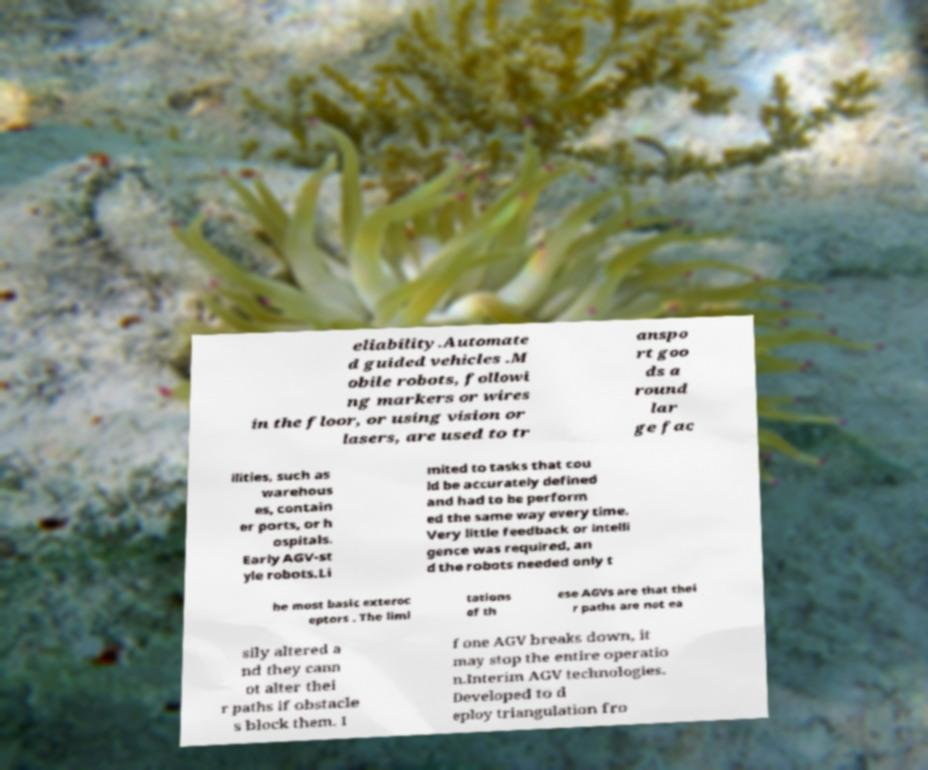For documentation purposes, I need the text within this image transcribed. Could you provide that? eliability.Automate d guided vehicles .M obile robots, followi ng markers or wires in the floor, or using vision or lasers, are used to tr anspo rt goo ds a round lar ge fac ilities, such as warehous es, contain er ports, or h ospitals. Early AGV-st yle robots.Li mited to tasks that cou ld be accurately defined and had to be perform ed the same way every time. Very little feedback or intelli gence was required, an d the robots needed only t he most basic exteroc eptors . The limi tations of th ese AGVs are that thei r paths are not ea sily altered a nd they cann ot alter thei r paths if obstacle s block them. I f one AGV breaks down, it may stop the entire operatio n.Interim AGV technologies. Developed to d eploy triangulation fro 